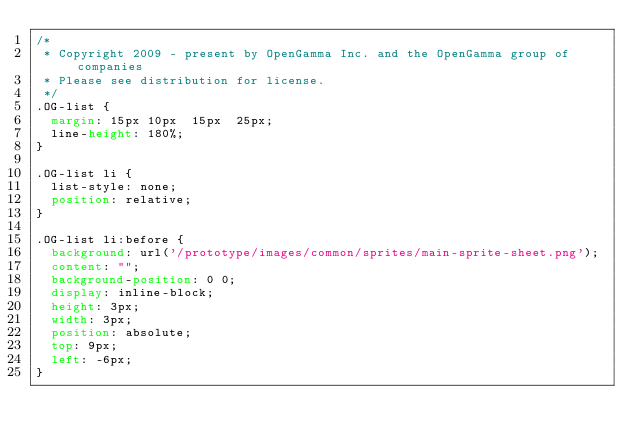Convert code to text. <code><loc_0><loc_0><loc_500><loc_500><_CSS_>/*
 * Copyright 2009 - present by OpenGamma Inc. and the OpenGamma group of companies
 * Please see distribution for license.
 */
.OG-list {
  margin: 15px 10px  15px  25px;
  line-height: 180%;
}

.OG-list li {
  list-style: none;
  position: relative;
}

.OG-list li:before {
  background: url('/prototype/images/common/sprites/main-sprite-sheet.png');
  content: "";
  background-position: 0 0;
  display: inline-block;
  height: 3px;
  width: 3px;
  position: absolute;
  top: 9px;
  left: -6px;
}
</code> 